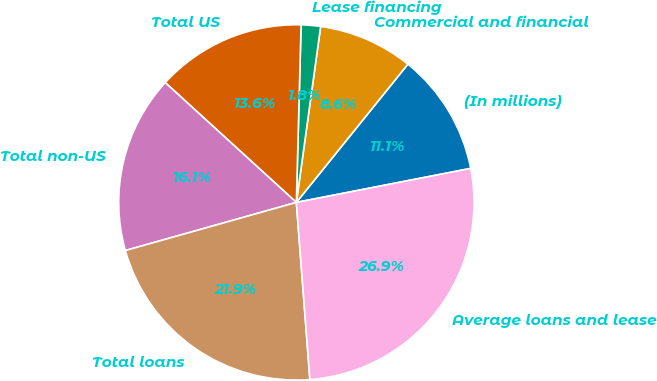<chart> <loc_0><loc_0><loc_500><loc_500><pie_chart><fcel>(In millions)<fcel>Commercial and financial<fcel>Lease financing<fcel>Total US<fcel>Total non-US<fcel>Total loans<fcel>Average loans and lease<nl><fcel>11.13%<fcel>8.62%<fcel>1.76%<fcel>13.64%<fcel>16.15%<fcel>21.85%<fcel>26.85%<nl></chart> 